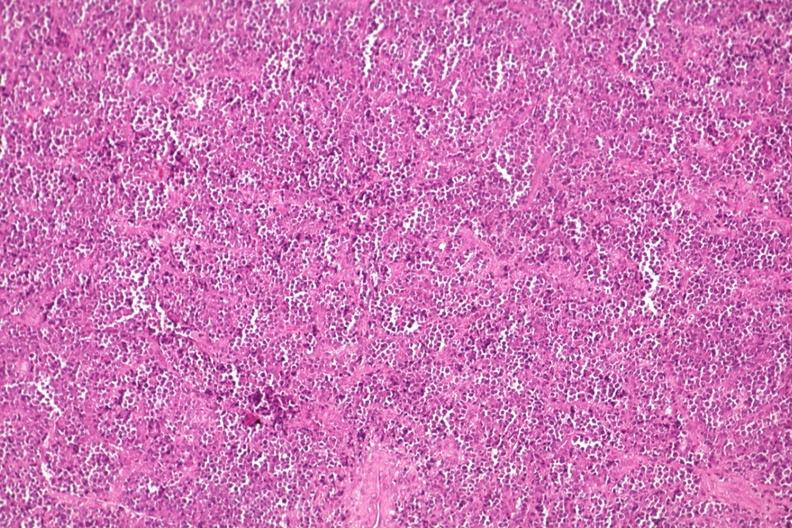what is present?
Answer the question using a single word or phrase. Joints 